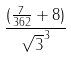<formula> <loc_0><loc_0><loc_500><loc_500>\frac { ( \frac { 7 } { 3 6 2 } + 8 ) } { \sqrt { 3 } ^ { 3 } }</formula> 